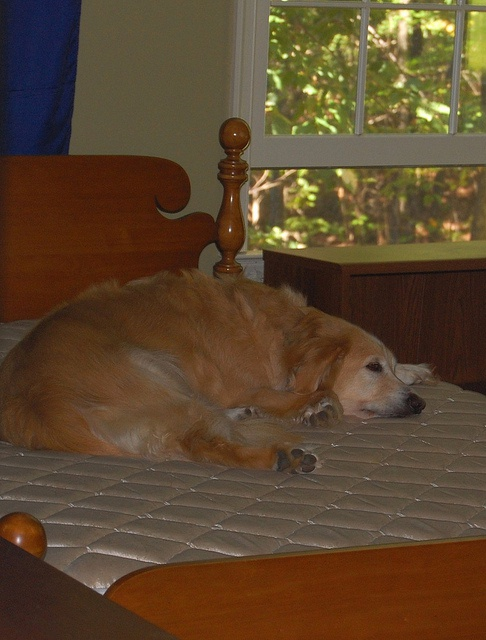Describe the objects in this image and their specific colors. I can see bed in black, maroon, and gray tones and dog in black, maroon, and gray tones in this image. 